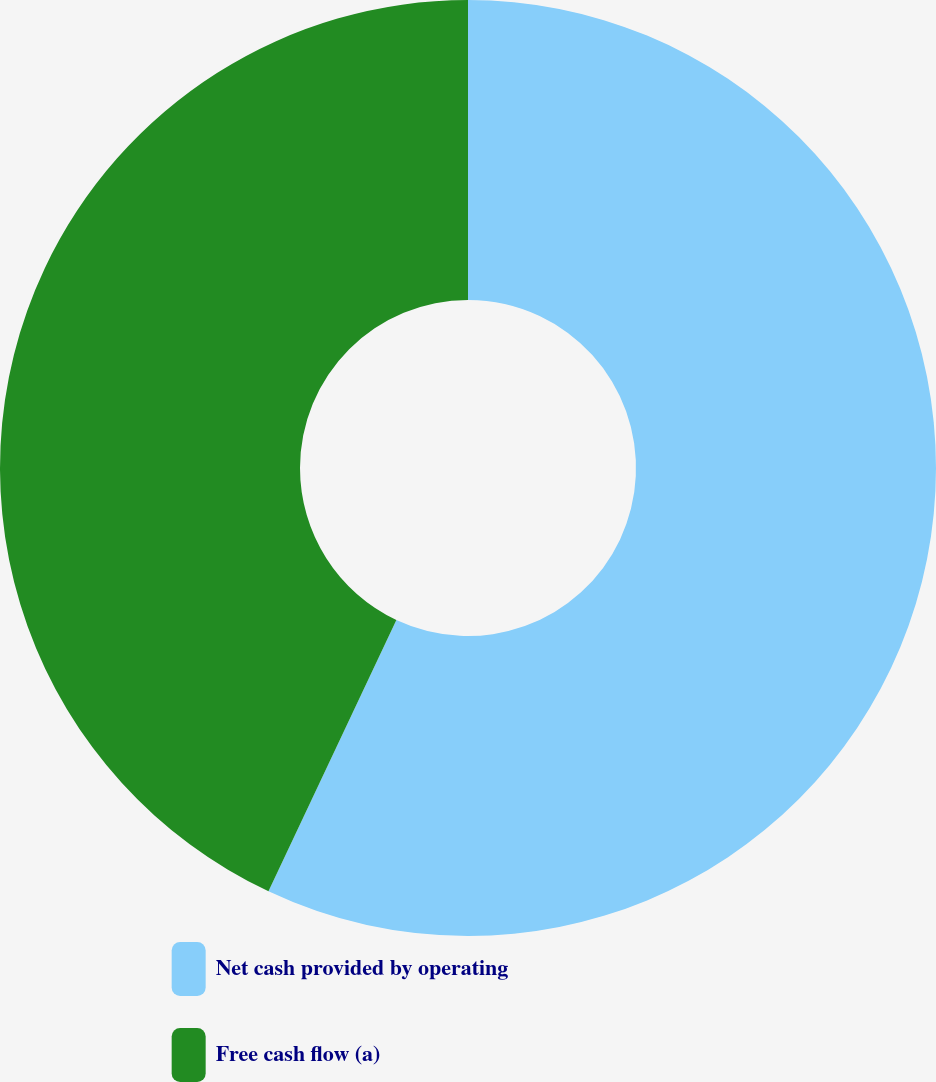Convert chart. <chart><loc_0><loc_0><loc_500><loc_500><pie_chart><fcel>Net cash provided by operating<fcel>Free cash flow (a)<nl><fcel>57.01%<fcel>42.99%<nl></chart> 